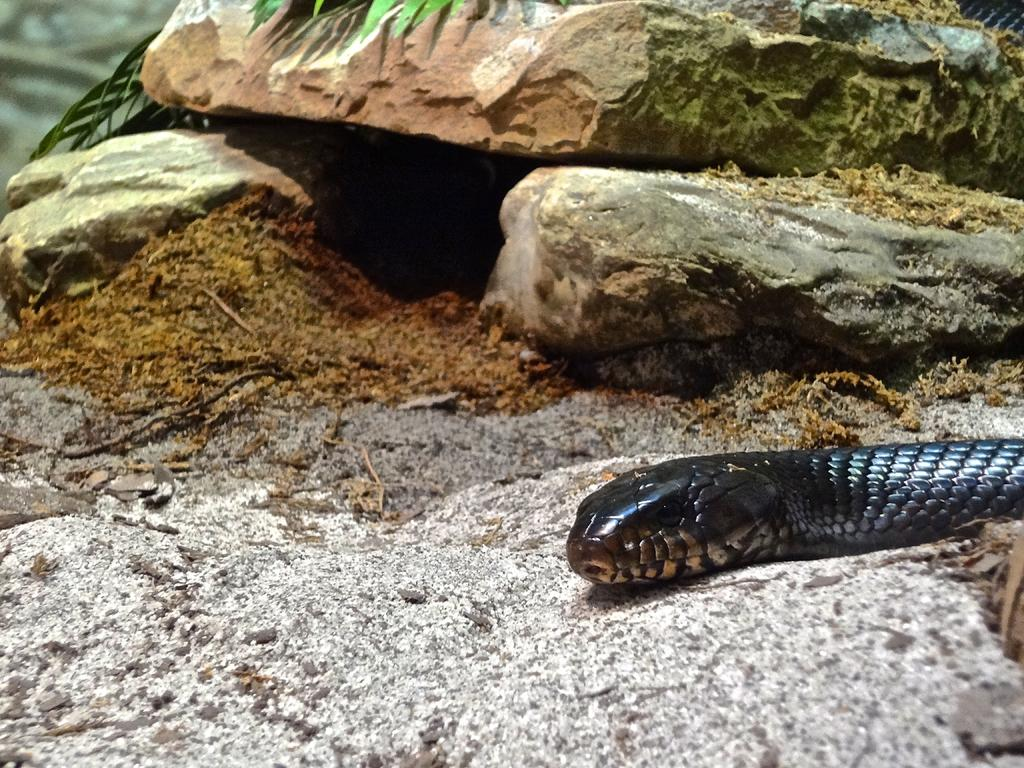What animal can be seen in the image? There is a snake in the image. Where is the snake located? The snake is on the land. What can be seen in the background of the image? There are rocks and leaves visible in the background of the image. What type of terrain is at the bottom of the image? There is land with stones at the bottom of the image. What type of watch is the snake wearing in the image? There is no watch present in the image; the snake is not wearing any accessories. 